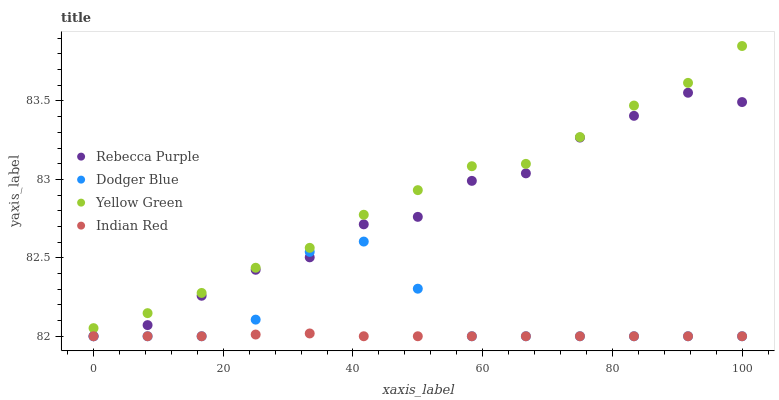Does Indian Red have the minimum area under the curve?
Answer yes or no. Yes. Does Yellow Green have the maximum area under the curve?
Answer yes or no. Yes. Does Rebecca Purple have the minimum area under the curve?
Answer yes or no. No. Does Rebecca Purple have the maximum area under the curve?
Answer yes or no. No. Is Indian Red the smoothest?
Answer yes or no. Yes. Is Dodger Blue the roughest?
Answer yes or no. Yes. Is Rebecca Purple the smoothest?
Answer yes or no. No. Is Rebecca Purple the roughest?
Answer yes or no. No. Does Dodger Blue have the lowest value?
Answer yes or no. Yes. Does Yellow Green have the lowest value?
Answer yes or no. No. Does Yellow Green have the highest value?
Answer yes or no. Yes. Does Rebecca Purple have the highest value?
Answer yes or no. No. Is Dodger Blue less than Yellow Green?
Answer yes or no. Yes. Is Yellow Green greater than Indian Red?
Answer yes or no. Yes. Does Indian Red intersect Rebecca Purple?
Answer yes or no. Yes. Is Indian Red less than Rebecca Purple?
Answer yes or no. No. Is Indian Red greater than Rebecca Purple?
Answer yes or no. No. Does Dodger Blue intersect Yellow Green?
Answer yes or no. No. 